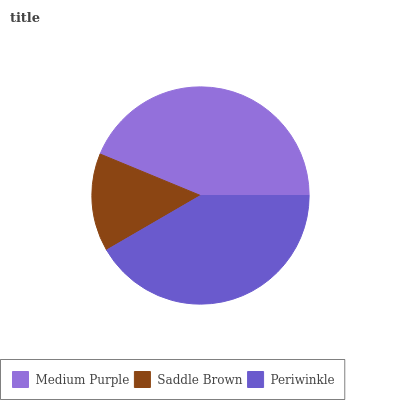Is Saddle Brown the minimum?
Answer yes or no. Yes. Is Medium Purple the maximum?
Answer yes or no. Yes. Is Periwinkle the minimum?
Answer yes or no. No. Is Periwinkle the maximum?
Answer yes or no. No. Is Periwinkle greater than Saddle Brown?
Answer yes or no. Yes. Is Saddle Brown less than Periwinkle?
Answer yes or no. Yes. Is Saddle Brown greater than Periwinkle?
Answer yes or no. No. Is Periwinkle less than Saddle Brown?
Answer yes or no. No. Is Periwinkle the high median?
Answer yes or no. Yes. Is Periwinkle the low median?
Answer yes or no. Yes. Is Medium Purple the high median?
Answer yes or no. No. Is Medium Purple the low median?
Answer yes or no. No. 